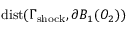<formula> <loc_0><loc_0><loc_500><loc_500>{ d i s t } ( \Gamma _ { s h o c k } , \partial B _ { 1 } ( O _ { 2 } ) )</formula> 